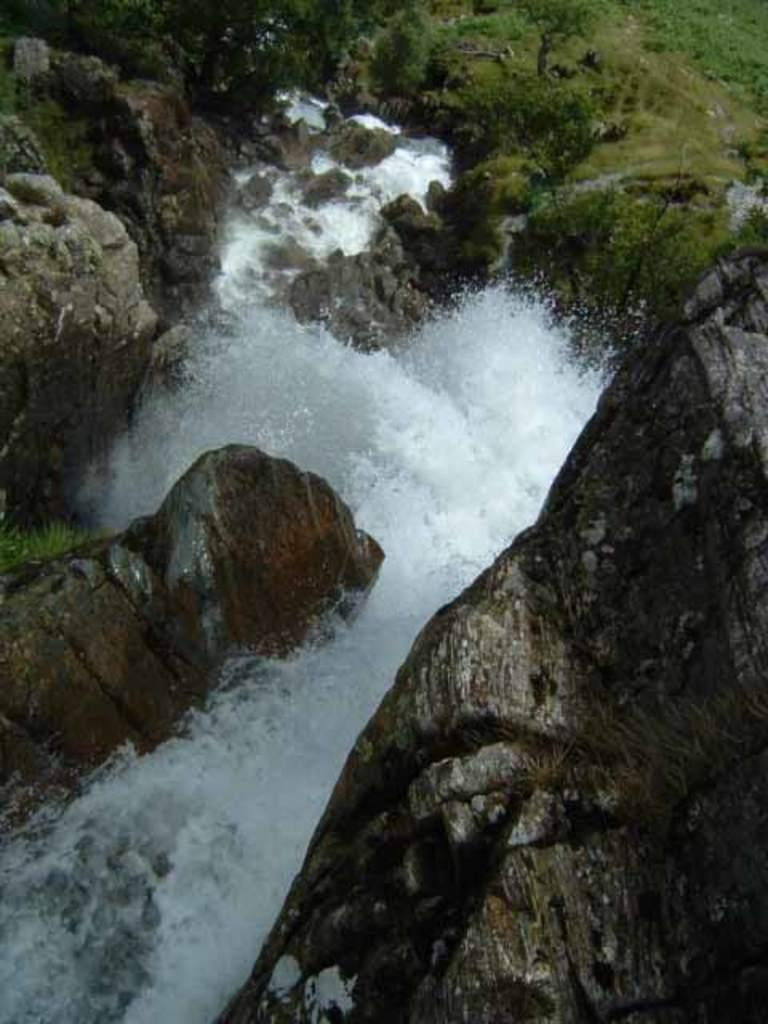What type of natural elements can be seen in the image? There are rocks, water, and plants visible in the image. What is the surface at the bottom of the image made of? There is grass on the surface at the bottom of the image. Where is the faucet located in the image? There is no faucet present in the image. What type of curve can be seen in the image? The image does not depict any curves; it features rocks, water, plants, and grass. 